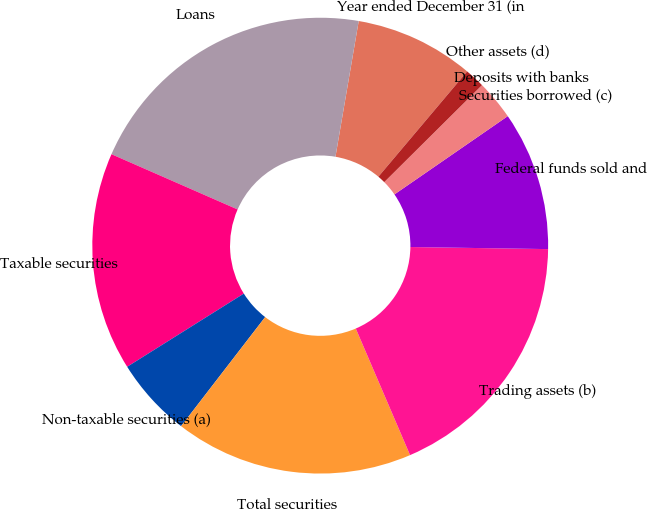Convert chart. <chart><loc_0><loc_0><loc_500><loc_500><pie_chart><fcel>Year ended December 31 (in<fcel>Loans<fcel>Taxable securities<fcel>Non-taxable securities (a)<fcel>Total securities<fcel>Trading assets (b)<fcel>Federal funds sold and<fcel>Securities borrowed (c)<fcel>Deposits with banks<fcel>Other assets (d)<nl><fcel>8.45%<fcel>21.13%<fcel>15.49%<fcel>5.63%<fcel>16.9%<fcel>18.31%<fcel>9.86%<fcel>0.0%<fcel>2.82%<fcel>1.41%<nl></chart> 